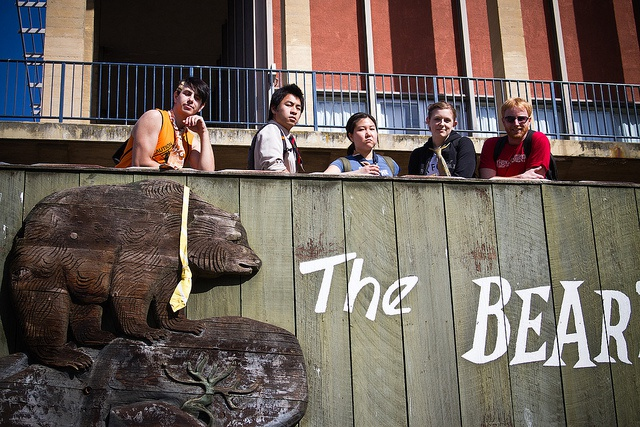Describe the objects in this image and their specific colors. I can see people in navy, maroon, black, lightpink, and lightgray tones, people in navy, black, maroon, brown, and lightgray tones, people in navy, white, black, gray, and maroon tones, people in navy, black, gray, maroon, and lightgray tones, and people in navy, lightgray, black, darkgray, and brown tones in this image. 